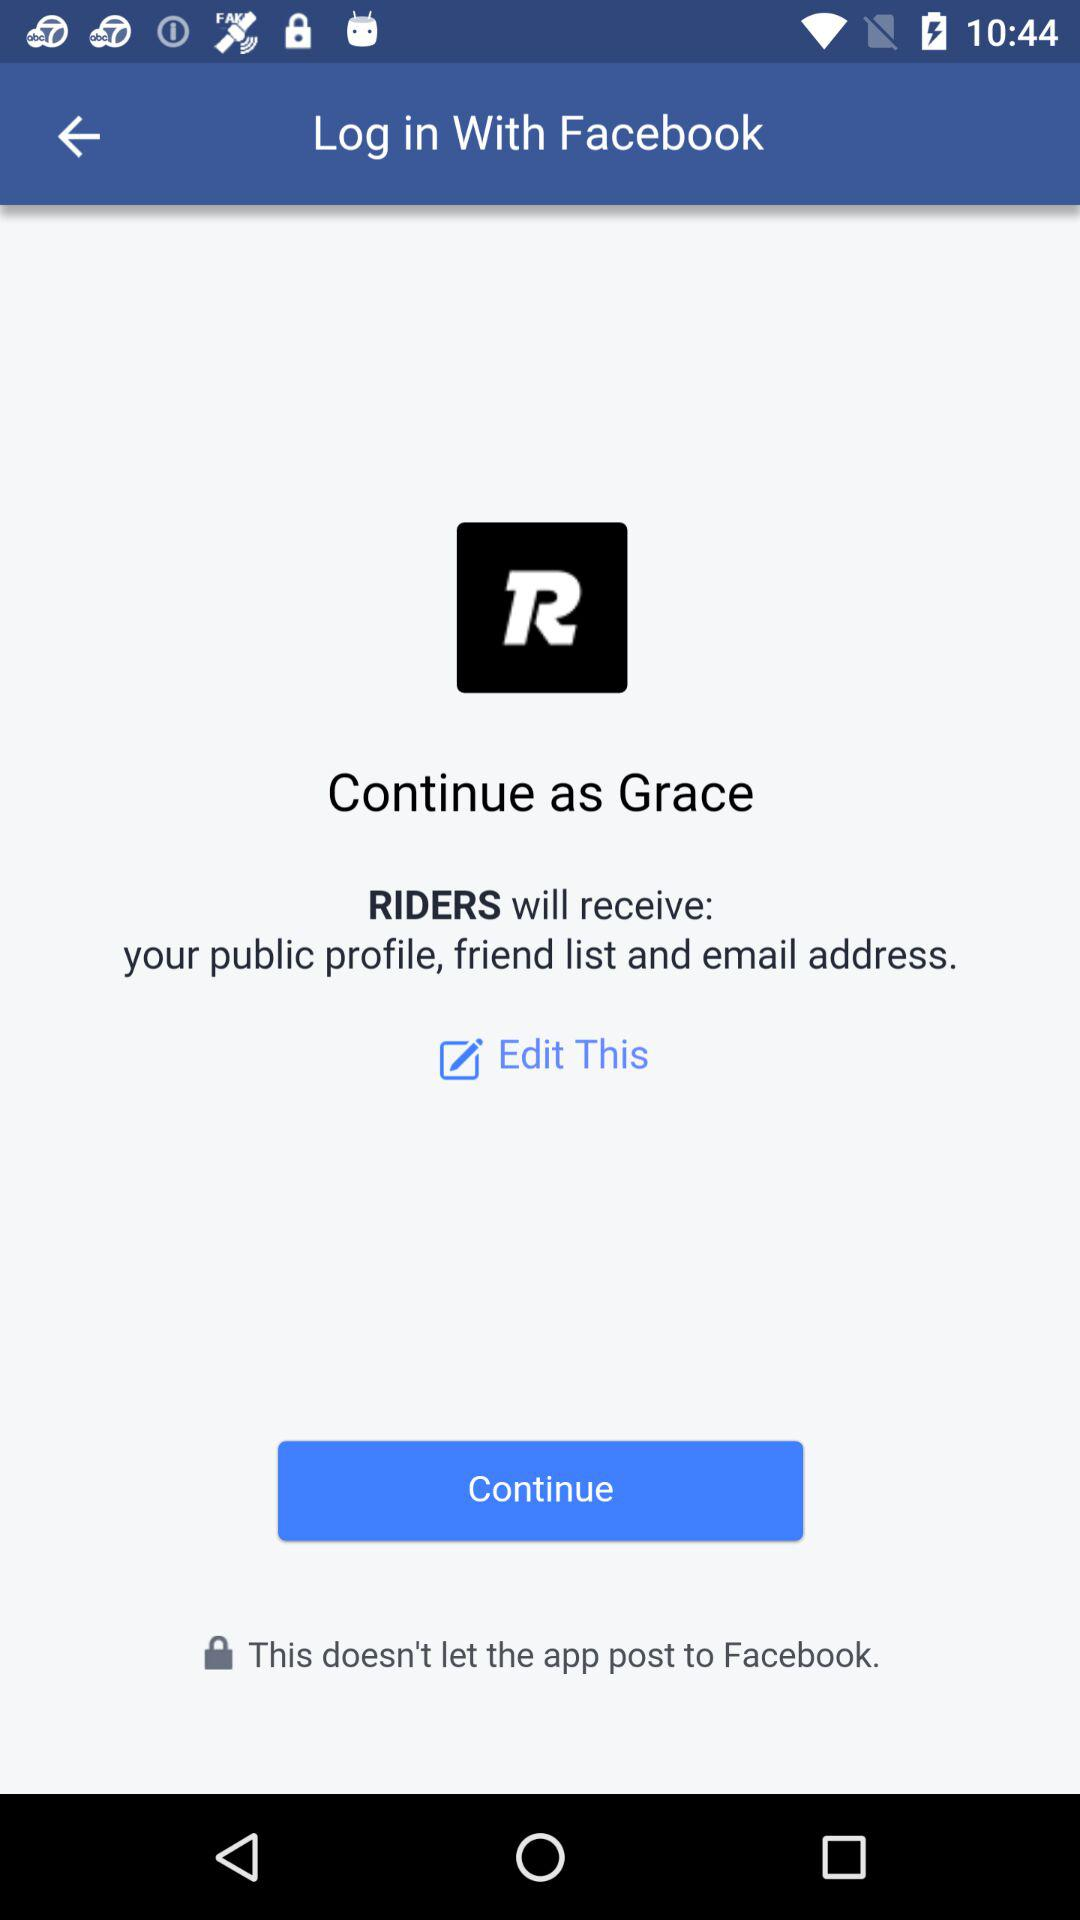What application will receive a public profile, friend list and email address? The application is "RIDERS". 